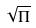Convert formula to latex. <formula><loc_0><loc_0><loc_500><loc_500>\sqrt { \Pi }</formula> 